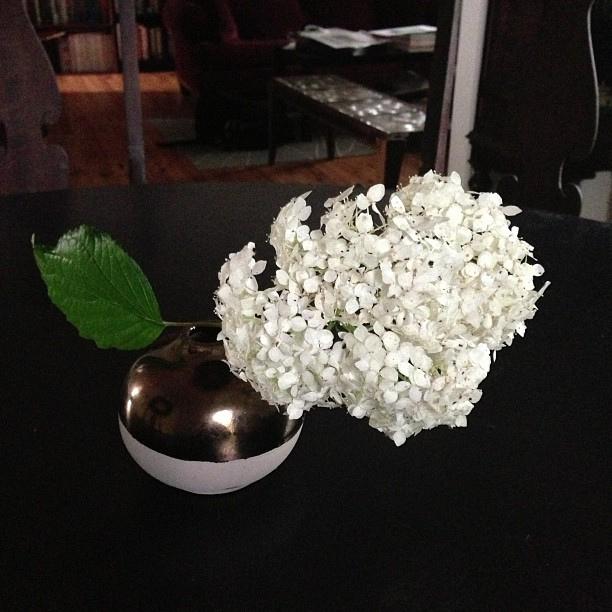How many leafs does this flower have?
Be succinct. 1. Does the leaf have any tears in it?
Quick response, please. Yes. Is the bouquet arrangement symmetric or asymmetric in composition?
Answer briefly. Asymmetric. 